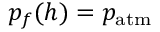<formula> <loc_0><loc_0><loc_500><loc_500>p _ { f } ( h ) = p _ { a t m }</formula> 